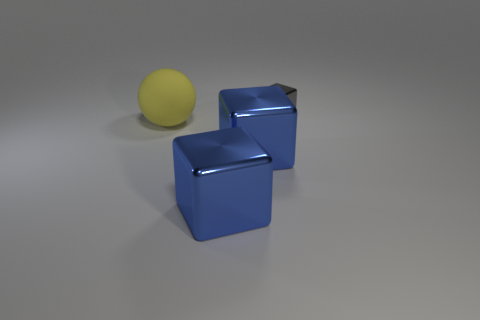Is there any other thing that is made of the same material as the sphere?
Make the answer very short. No. What number of objects are either gray things or cubes in front of the small shiny thing?
Ensure brevity in your answer.  3. Are there more large objects on the left side of the small gray shiny thing than small metal objects that are to the right of the matte sphere?
Offer a very short reply. Yes. Are there any blocks that are behind the metallic object behind the big ball?
Keep it short and to the point. No. What size is the gray metallic object?
Offer a terse response. Small. How many things are metallic cubes or gray metal blocks?
Keep it short and to the point. 3. What number of other rubber objects have the same size as the gray object?
Provide a succinct answer. 0. How many other things are the same color as the rubber object?
Your response must be concise. 0. Is there any other thing that has the same size as the matte sphere?
Provide a short and direct response. Yes. Is the number of objects in front of the small cube the same as the number of large yellow spheres that are behind the big rubber thing?
Keep it short and to the point. No. 